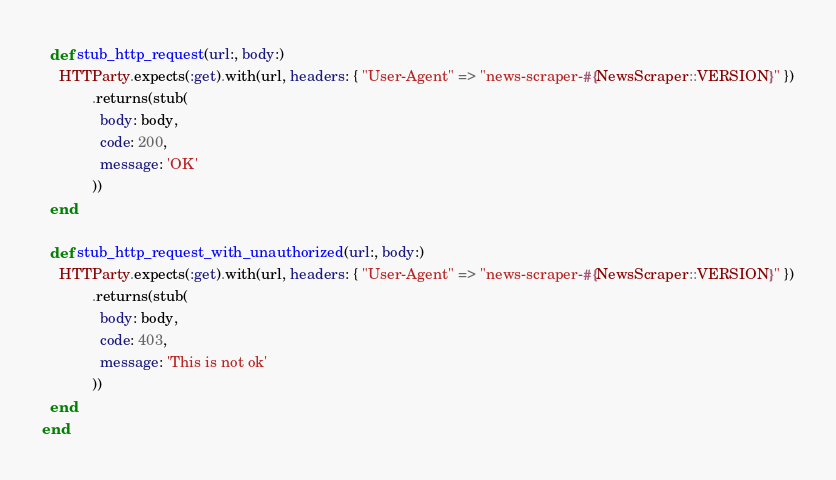Convert code to text. <code><loc_0><loc_0><loc_500><loc_500><_Ruby_>  def stub_http_request(url:, body:)
    HTTParty.expects(:get).with(url, headers: { "User-Agent" => "news-scraper-#{NewsScraper::VERSION}" })
            .returns(stub(
              body: body,
              code: 200,
              message: 'OK'
            ))
  end

  def stub_http_request_with_unauthorized(url:, body:)
    HTTParty.expects(:get).with(url, headers: { "User-Agent" => "news-scraper-#{NewsScraper::VERSION}" })
            .returns(stub(
              body: body,
              code: 403,
              message: 'This is not ok'
            ))
  end
end
</code> 